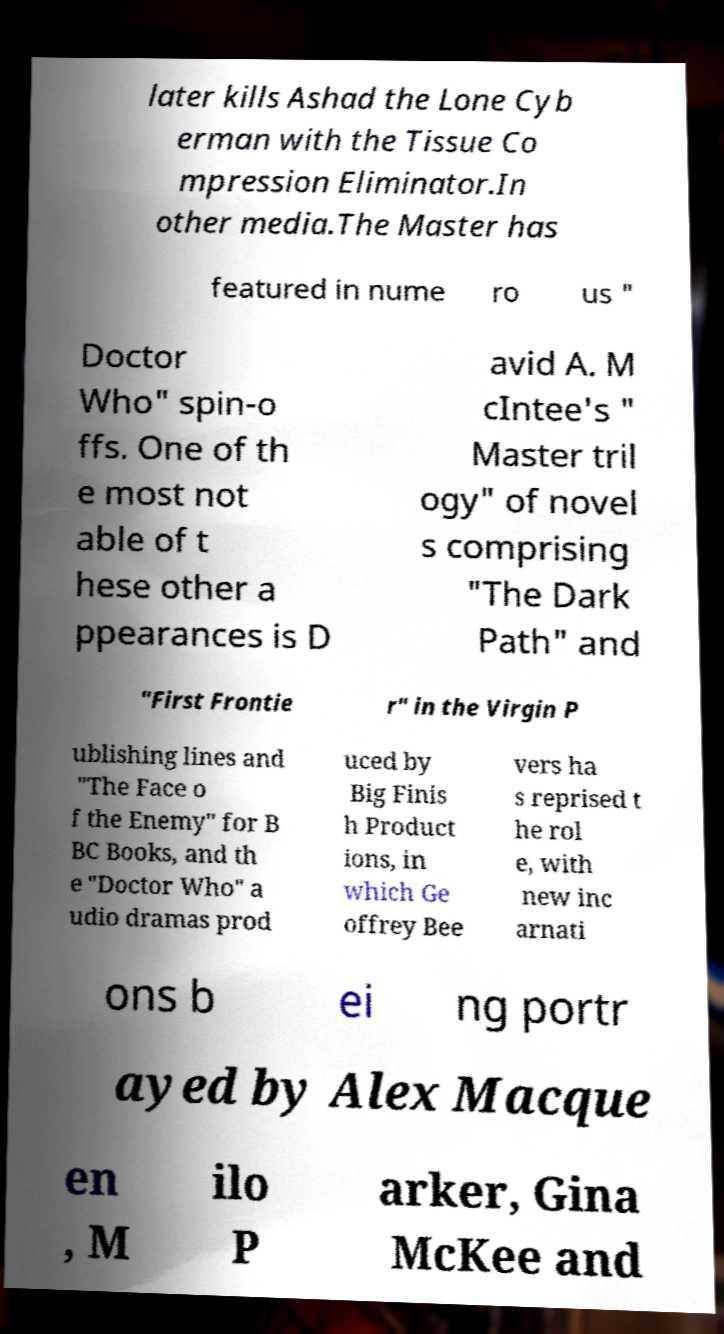Please identify and transcribe the text found in this image. later kills Ashad the Lone Cyb erman with the Tissue Co mpression Eliminator.In other media.The Master has featured in nume ro us " Doctor Who" spin-o ffs. One of th e most not able of t hese other a ppearances is D avid A. M cIntee's " Master tril ogy" of novel s comprising "The Dark Path" and "First Frontie r" in the Virgin P ublishing lines and "The Face o f the Enemy" for B BC Books, and th e "Doctor Who" a udio dramas prod uced by Big Finis h Product ions, in which Ge offrey Bee vers ha s reprised t he rol e, with new inc arnati ons b ei ng portr ayed by Alex Macque en , M ilo P arker, Gina McKee and 